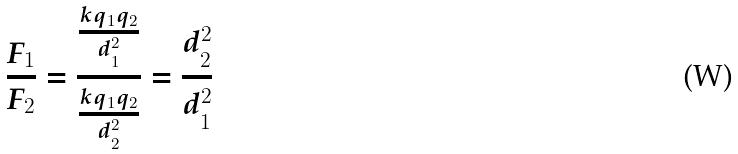Convert formula to latex. <formula><loc_0><loc_0><loc_500><loc_500>\frac { F _ { 1 } } { F _ { 2 } } = \frac { \frac { k q _ { 1 } q _ { 2 } } { d _ { 1 } ^ { 2 } } } { \frac { k q _ { 1 } q _ { 2 } } { d _ { 2 } ^ { 2 } } } = \frac { d _ { 2 } ^ { 2 } } { d _ { 1 } ^ { 2 } }</formula> 